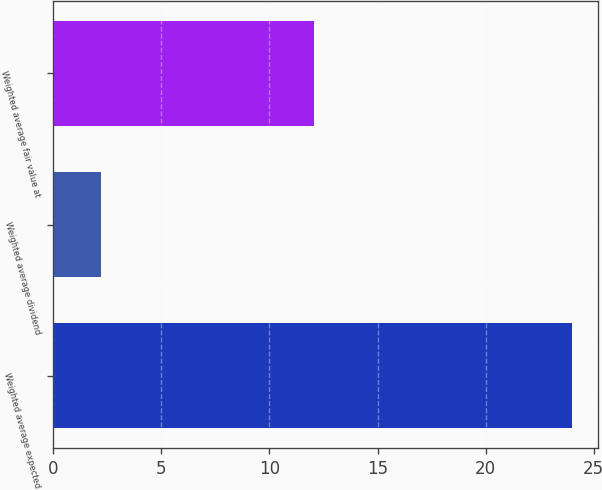Convert chart. <chart><loc_0><loc_0><loc_500><loc_500><bar_chart><fcel>Weighted average expected<fcel>Weighted average dividend<fcel>Weighted average fair value at<nl><fcel>24<fcel>2.2<fcel>12.08<nl></chart> 